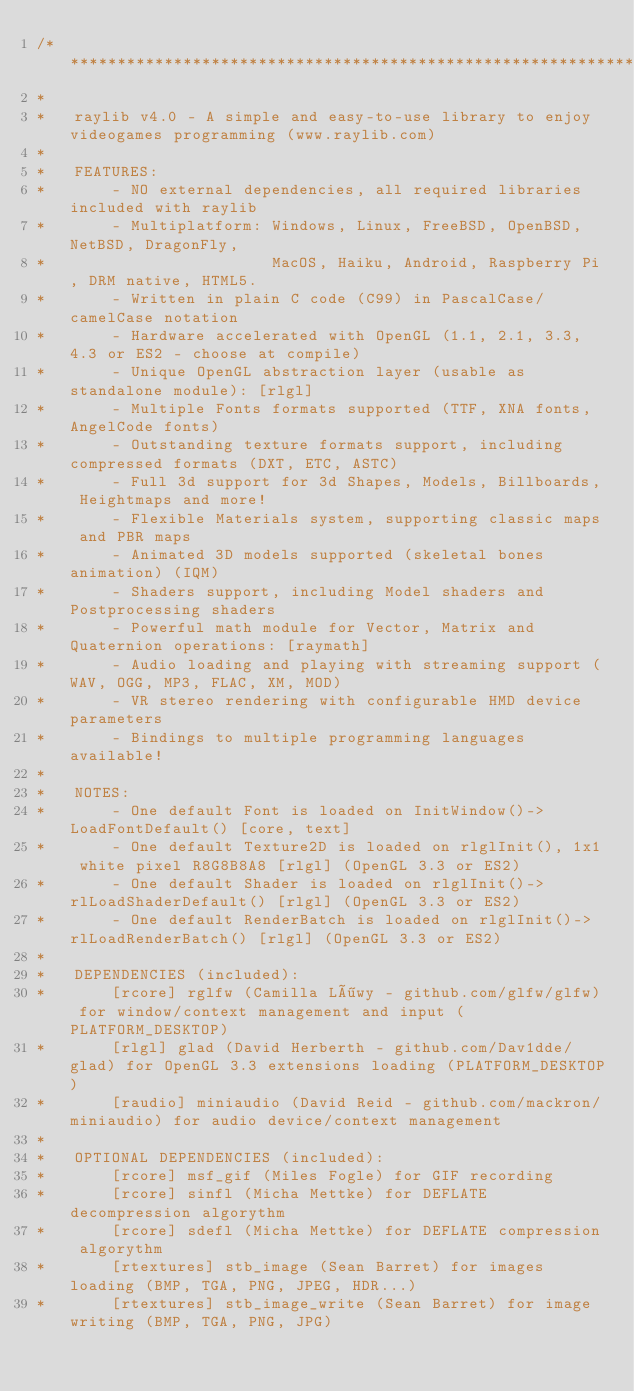<code> <loc_0><loc_0><loc_500><loc_500><_C_>/**********************************************************************************************
*
*   raylib v4.0 - A simple and easy-to-use library to enjoy videogames programming (www.raylib.com)
*
*   FEATURES:
*       - NO external dependencies, all required libraries included with raylib
*       - Multiplatform: Windows, Linux, FreeBSD, OpenBSD, NetBSD, DragonFly,
*                        MacOS, Haiku, Android, Raspberry Pi, DRM native, HTML5.
*       - Written in plain C code (C99) in PascalCase/camelCase notation
*       - Hardware accelerated with OpenGL (1.1, 2.1, 3.3, 4.3 or ES2 - choose at compile)
*       - Unique OpenGL abstraction layer (usable as standalone module): [rlgl]
*       - Multiple Fonts formats supported (TTF, XNA fonts, AngelCode fonts)
*       - Outstanding texture formats support, including compressed formats (DXT, ETC, ASTC)
*       - Full 3d support for 3d Shapes, Models, Billboards, Heightmaps and more!
*       - Flexible Materials system, supporting classic maps and PBR maps
*       - Animated 3D models supported (skeletal bones animation) (IQM)
*       - Shaders support, including Model shaders and Postprocessing shaders
*       - Powerful math module for Vector, Matrix and Quaternion operations: [raymath]
*       - Audio loading and playing with streaming support (WAV, OGG, MP3, FLAC, XM, MOD)
*       - VR stereo rendering with configurable HMD device parameters
*       - Bindings to multiple programming languages available!
*
*   NOTES:
*       - One default Font is loaded on InitWindow()->LoadFontDefault() [core, text]
*       - One default Texture2D is loaded on rlglInit(), 1x1 white pixel R8G8B8A8 [rlgl] (OpenGL 3.3 or ES2)
*       - One default Shader is loaded on rlglInit()->rlLoadShaderDefault() [rlgl] (OpenGL 3.3 or ES2)
*       - One default RenderBatch is loaded on rlglInit()->rlLoadRenderBatch() [rlgl] (OpenGL 3.3 or ES2)
*
*   DEPENDENCIES (included):
*       [rcore] rglfw (Camilla Löwy - github.com/glfw/glfw) for window/context management and input (PLATFORM_DESKTOP)
*       [rlgl] glad (David Herberth - github.com/Dav1dde/glad) for OpenGL 3.3 extensions loading (PLATFORM_DESKTOP)
*       [raudio] miniaudio (David Reid - github.com/mackron/miniaudio) for audio device/context management
*
*   OPTIONAL DEPENDENCIES (included):
*       [rcore] msf_gif (Miles Fogle) for GIF recording
*       [rcore] sinfl (Micha Mettke) for DEFLATE decompression algorythm
*       [rcore] sdefl (Micha Mettke) for DEFLATE compression algorythm
*       [rtextures] stb_image (Sean Barret) for images loading (BMP, TGA, PNG, JPEG, HDR...)
*       [rtextures] stb_image_write (Sean Barret) for image writing (BMP, TGA, PNG, JPG)</code> 